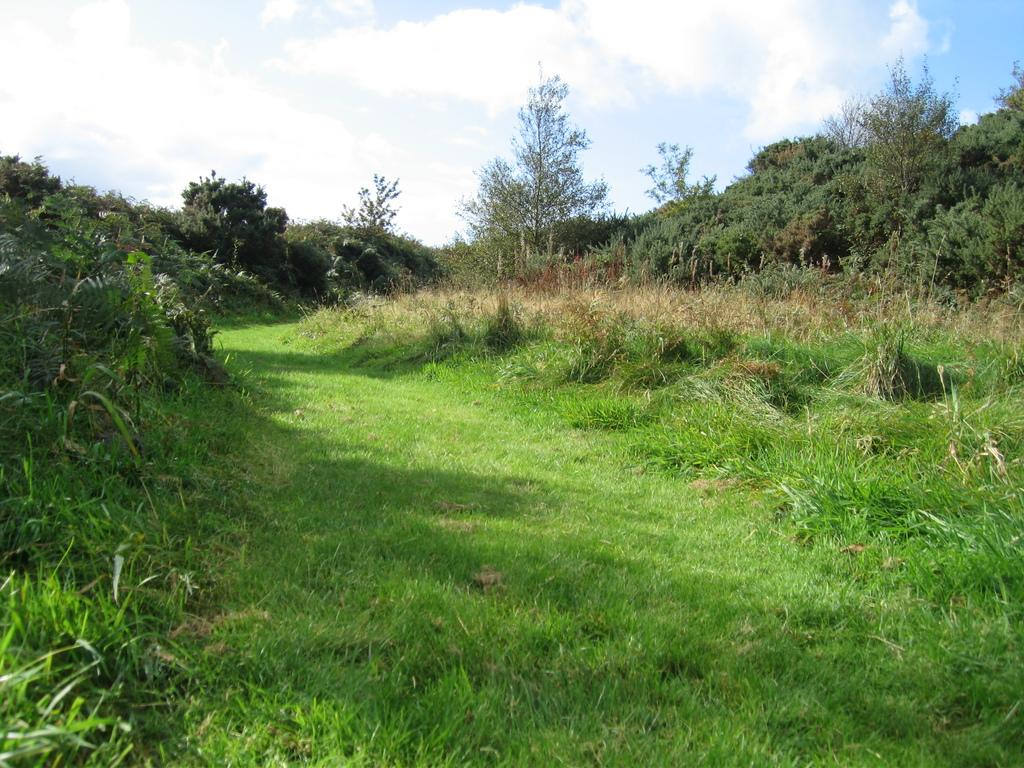What types of vegetation are present in the image? The image contains plants and trees. What is the color of the grass at the bottom of the image? There is green grass at the bottom of the image. What can be seen in the sky at the top of the image? There are clouds in the sky at the top of the image. What type of marble can be seen on the island in the image? There is no marble or island present in the image; it features plants, trees, and grass. What is the carpenter doing on the island in the image? There is no carpenter or island present in the image, so it is not possible to determine what the carpenter might be doing. 